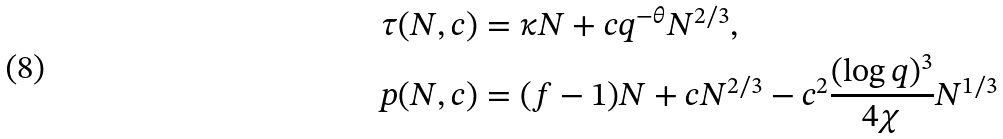Convert formula to latex. <formula><loc_0><loc_0><loc_500><loc_500>\tau ( N , c ) & = \kappa N + c q ^ { - \theta } N ^ { 2 / 3 } , \\ p ( N , c ) & = ( f - 1 ) N + c N ^ { 2 / 3 } - c ^ { 2 } \frac { ( \log q ) ^ { 3 } } { 4 \chi } N ^ { 1 / 3 }</formula> 